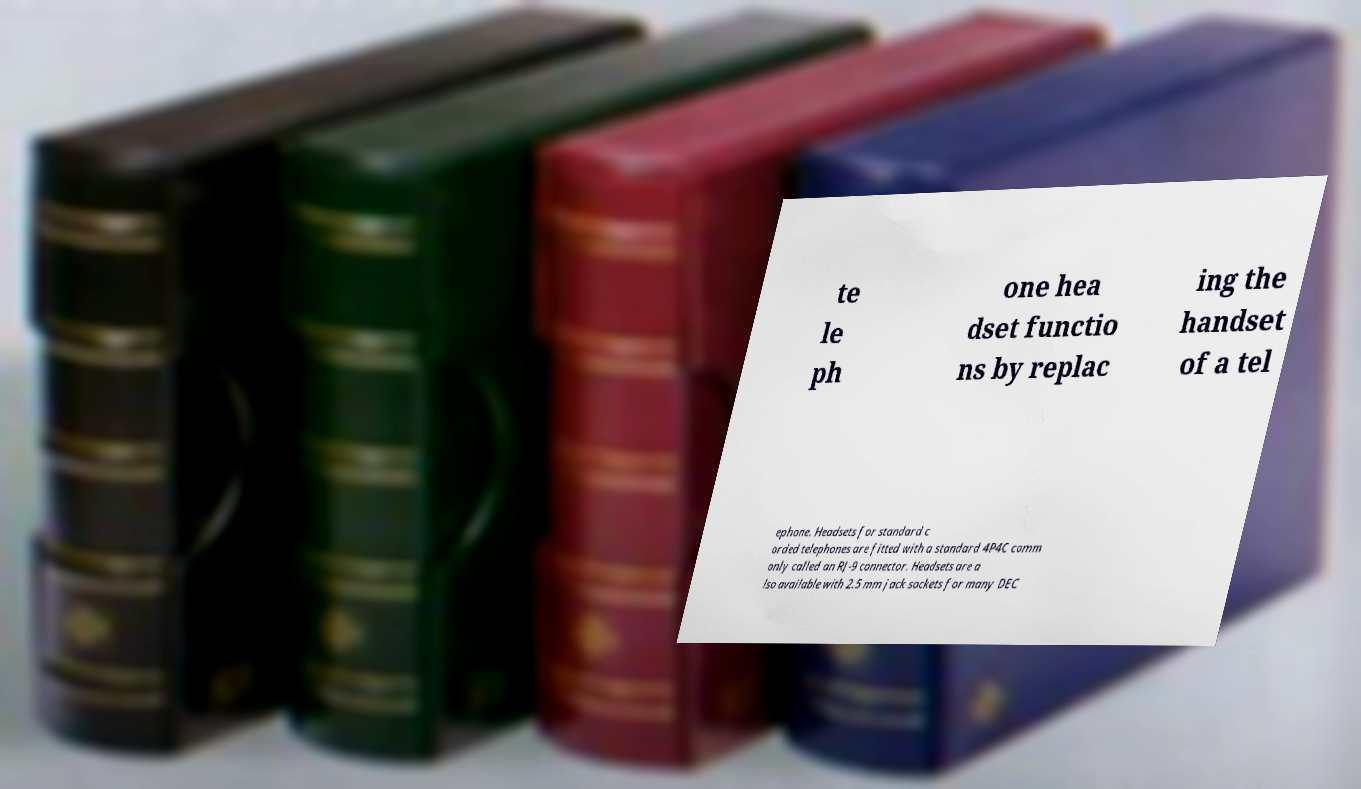Please read and relay the text visible in this image. What does it say? te le ph one hea dset functio ns by replac ing the handset of a tel ephone. Headsets for standard c orded telephones are fitted with a standard 4P4C comm only called an RJ-9 connector. Headsets are a lso available with 2.5 mm jack sockets for many DEC 